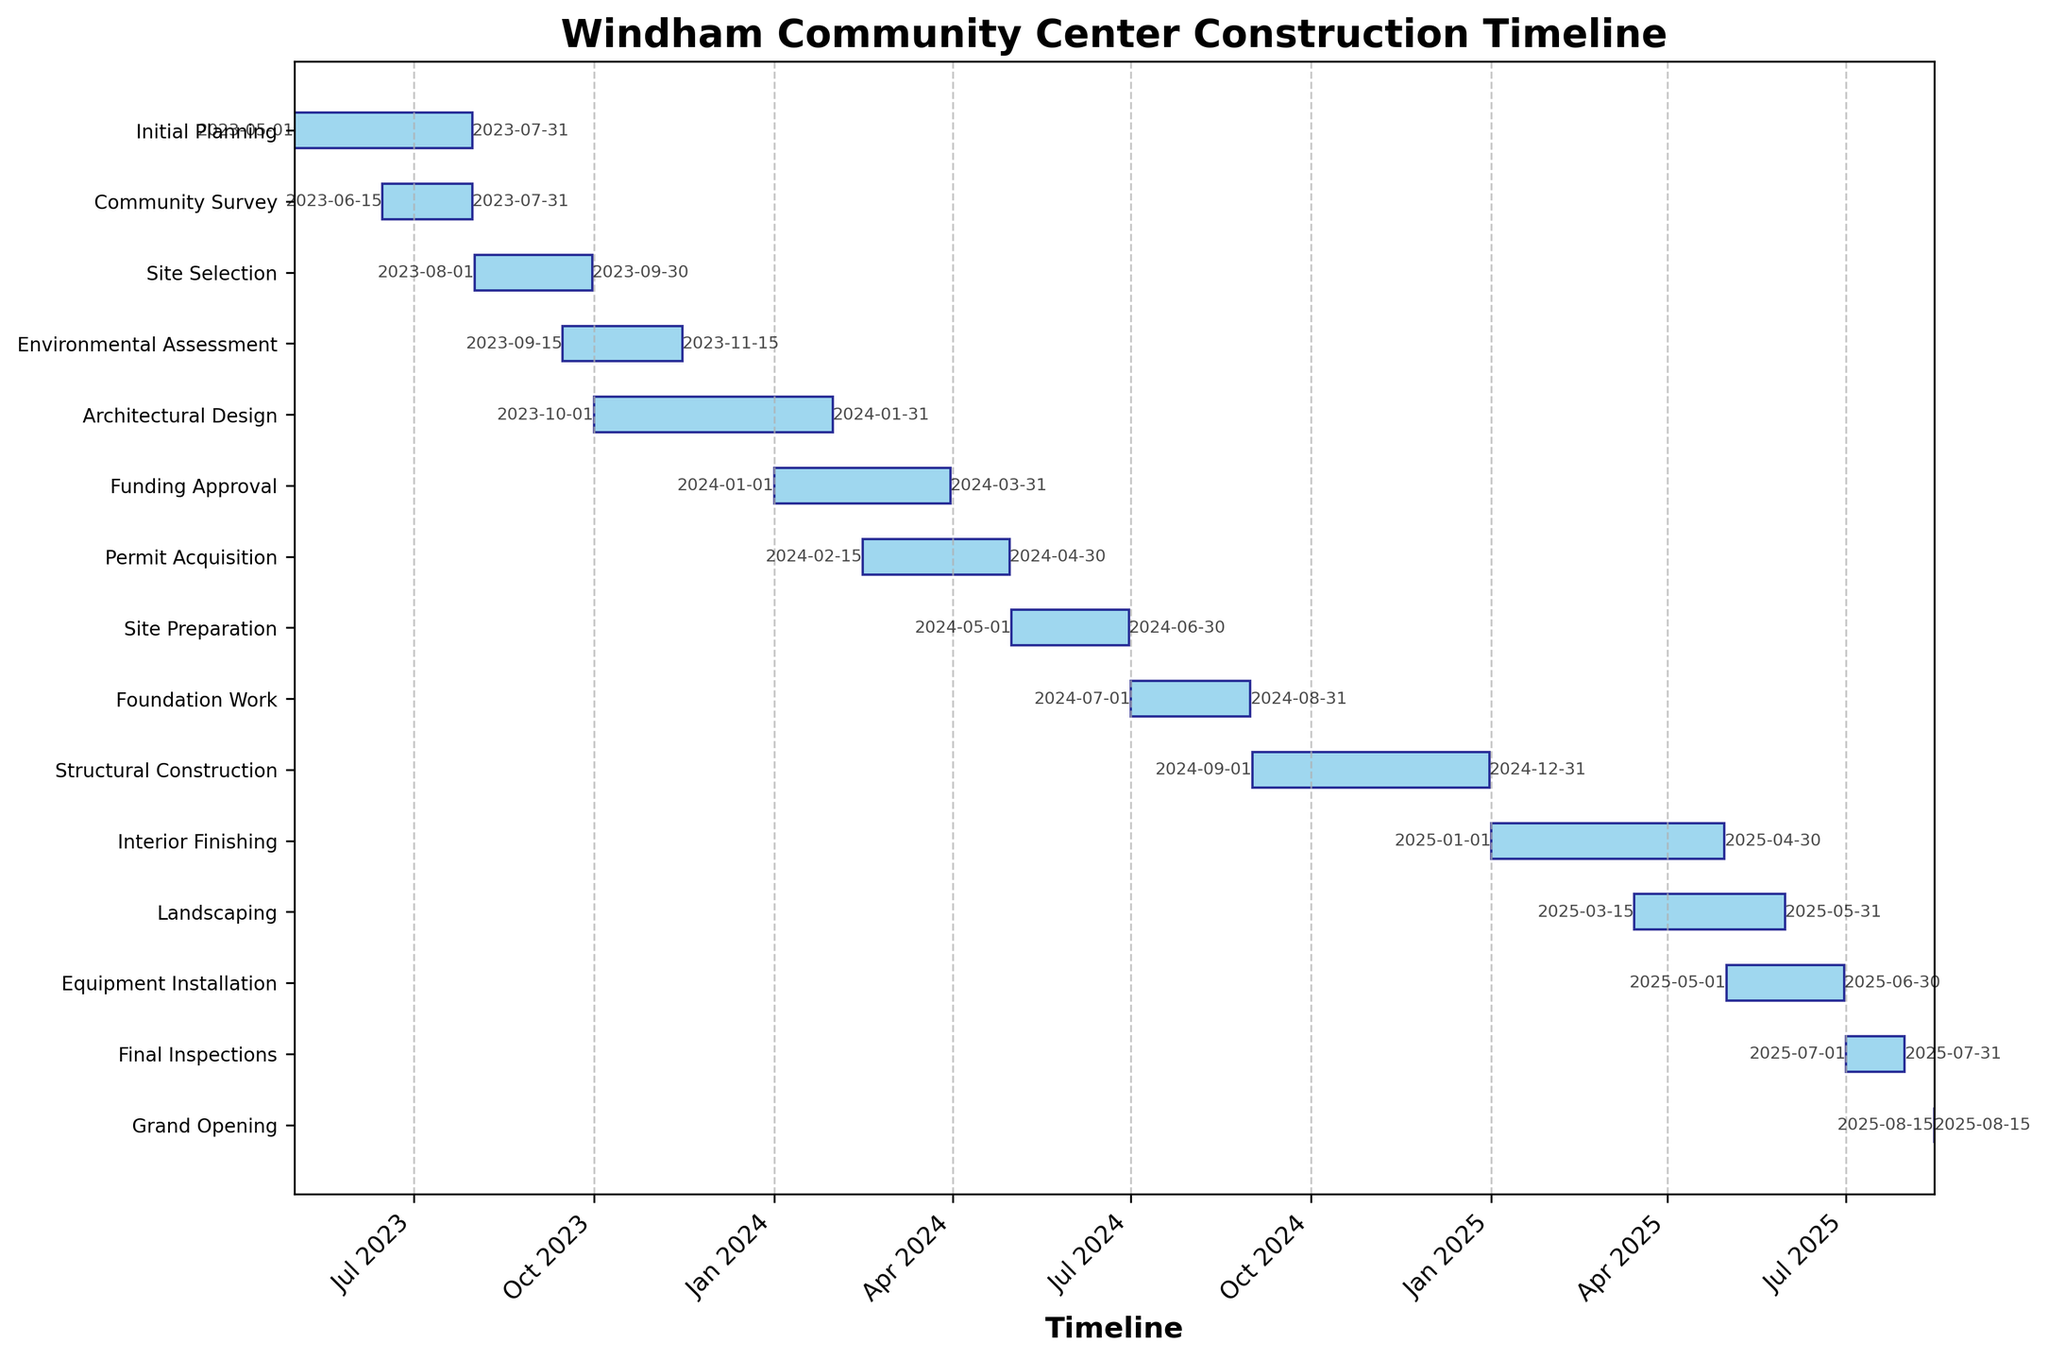How long is the Foundation Work phase? The Foundation Work phase starts on 2024-07-01 and ends on 2024-08-31. The duration is calculated by counting the total days between these dates.
Answer: 2 months What is the duration of the Environmental Assessment phase? The Environmental Assessment phase starts on 2023-09-15 and ends on 2023-11-15. To find the duration, calculate the total days between these dates.
Answer: 2 months Which phase directly follows Site Preparation? Site Preparation ends on 2024-06-30. The next phase to start is Foundation Work, which begins on 2024-07-01.
Answer: Foundation Work How many phases are there in total? Counting the number of different tasks/activities listed on the chart gives the total number of phases. Each unique bar represents a phase.
Answer: 14 What phases are ongoing during November 2023? In November 2023, the chart shows the Environmental Assessment and Architectural Design as ongoing activities. Checking the start and end dates confirms these activities extend through November.
Answer: Environmental Assessment, Architectural Design Which is shorter, the Interior Finishing phase or the Landscaping phase? The Interior Finishing phase runs from 2025-01-01 to 2025-04-30, lasting about 4 months. The Landscaping phase runs from 2025-03-15 to 2025-05-31, lasting about 2.5 months. Comparing these durations shows which is shorter.
Answer: Landscaping How much time elapses from the start of Initial Planning to the Grand Opening? Initially planning begins on 2023-05-01 and the Grand Opening is on 2025-08-15. By calculating the time between these two dates, the total time elapsed is found.
Answer: About 2 years and 3.5 months Which phase has the same start and end date? Reviewing the start and end dates for all phases reveals that the Grand Opening takes place on a single day, 2025-08-15.
Answer: Grand Opening In which month and year does the Permit Acquisition phase end? The Permit Acquisition phase ends on 2024-04-30. This is within the month of April in the year 2024.
Answer: April 2024 